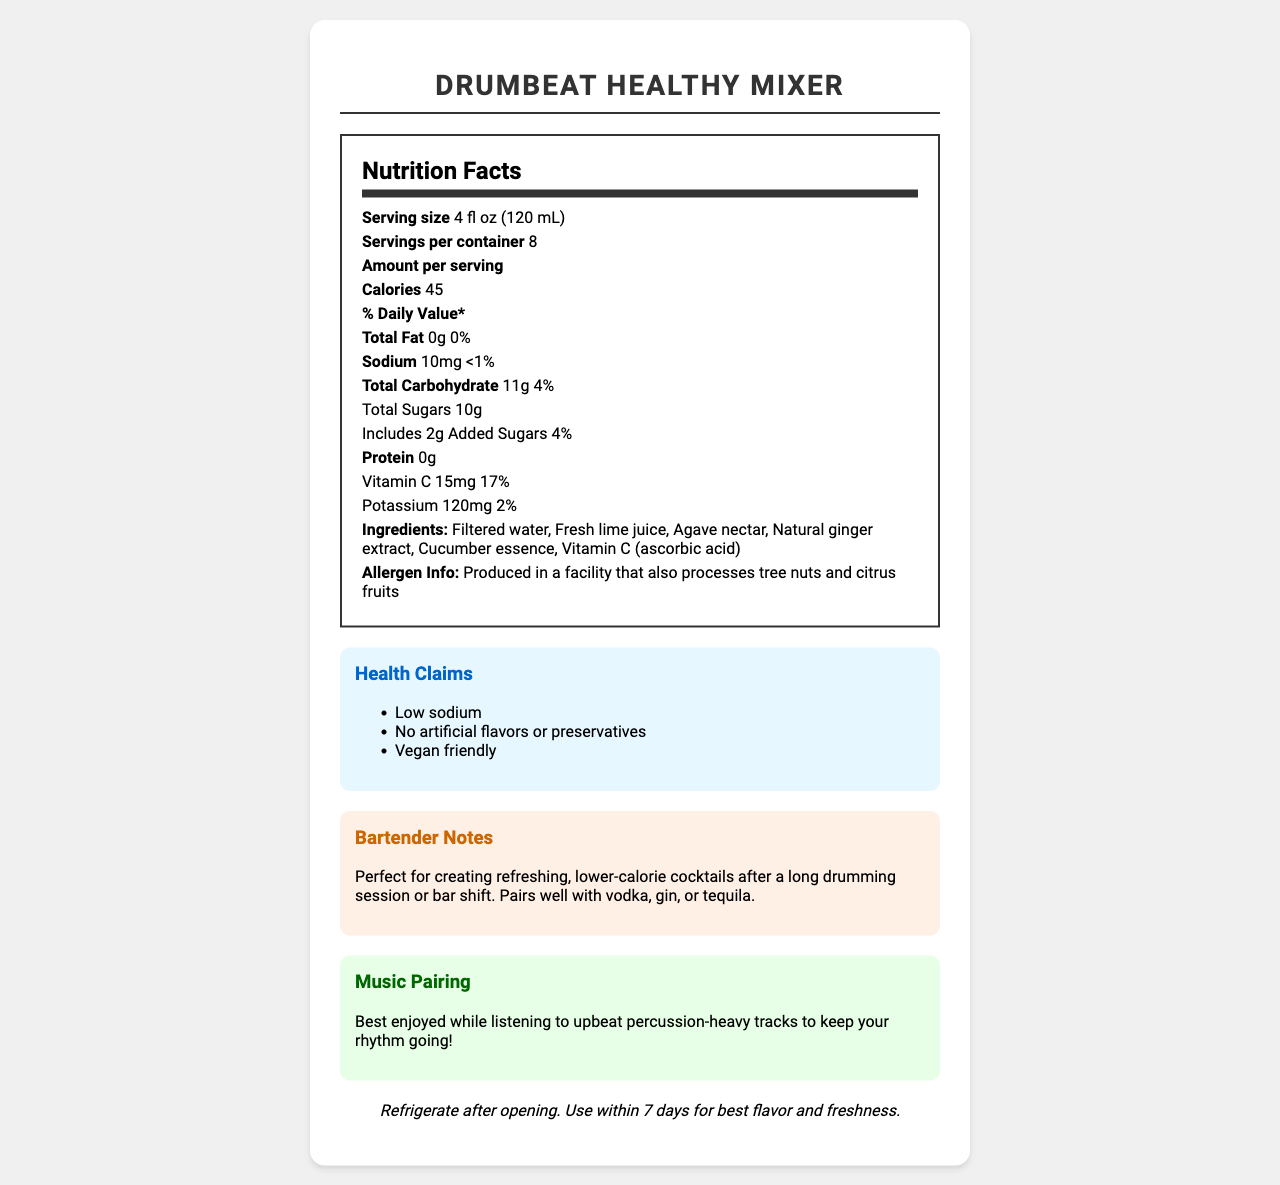what is the serving size of DrumBeat Healthy Mixer? As mentioned under "Serving size," the serving size is 4 fluid ounces, which is also equivalent to 120 milliliters.
Answer: 4 fl oz (120 mL) how many servings are in one container of DrumBeat Healthy Mixer? The "Servings per container" is listed as 8.
Answer: 8 how many calories are in one serving? The document lists the "Calories" as 45 per serving.
Answer: 45 what is the amount of sodium per serving? Under "Sodium," the document states there are 10 milligrams of sodium per serving.
Answer: 10mg what is the daily value percentage for Vitamin C in a serving? The daily value for Vitamin C is listed as 17%.
Answer: 17% what are the main ingredients in DrumBeat Healthy Mixer? The main ingredients are listed under "Ingredients."
Answer: Filtered water, Fresh lime juice, Agave nectar, Natural ginger extract, Cucumber essence, Vitamin C (ascorbic acid) which of the following health claims is NOT made for DrumBeat Healthy Mixer? A. Low sodium B. Contains artificial flavors C. No preservatives D. Vegan friendly The health claims listed include "Low sodium," "No artificial flavors or preservatives," and "Vegan friendly." Thus, "Contains artificial flavors" is not a claim made for this product.
Answer: B what is the correct storage instruction for DrumBeat Healthy Mixer? A. Store in a cool, dry place B. Refrigerate after opening C. Keep at room temperature D. Shake well before use The storage instruction is "Refrigerate after opening. Use within 7 days for best flavor and freshness."
Answer: B is DrumBeat Healthy Mixer suitable for vegans? One of the health claims mentions "Vegan friendly," indicating it is suitable for vegans.
Answer: Yes describe the purpose of the "Bartender Notes" section in the document. The "Bartender Notes" section explains that the mixer is perfect for creating refreshing, lower-calorie cocktails after activities like drumming or a bar shift. It also suggests pairing it with vodka, gin, or tequila.
Answer: A description of how the mixer is ideal for making low-calorie cocktails and pairing suggestions with various spirits. what is the specific amount of added sugars in one serving? The document specifies that there are 2 grams of added sugars in one serving.
Answer: 2g how many grams of protein are in each serving? The "Protein" section lists 0 grams of protein per serving.
Answer: 0g can I determine if the product contains gluten based on the document? The document does not provide any information regarding the presence or absence of gluten.
Answer: Cannot be determined 